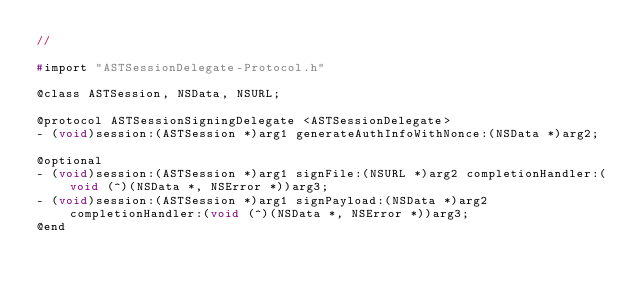Convert code to text. <code><loc_0><loc_0><loc_500><loc_500><_C_>//

#import "ASTSessionDelegate-Protocol.h"

@class ASTSession, NSData, NSURL;

@protocol ASTSessionSigningDelegate <ASTSessionDelegate>
- (void)session:(ASTSession *)arg1 generateAuthInfoWithNonce:(NSData *)arg2;

@optional
- (void)session:(ASTSession *)arg1 signFile:(NSURL *)arg2 completionHandler:(void (^)(NSData *, NSError *))arg3;
- (void)session:(ASTSession *)arg1 signPayload:(NSData *)arg2 completionHandler:(void (^)(NSData *, NSError *))arg3;
@end

</code> 